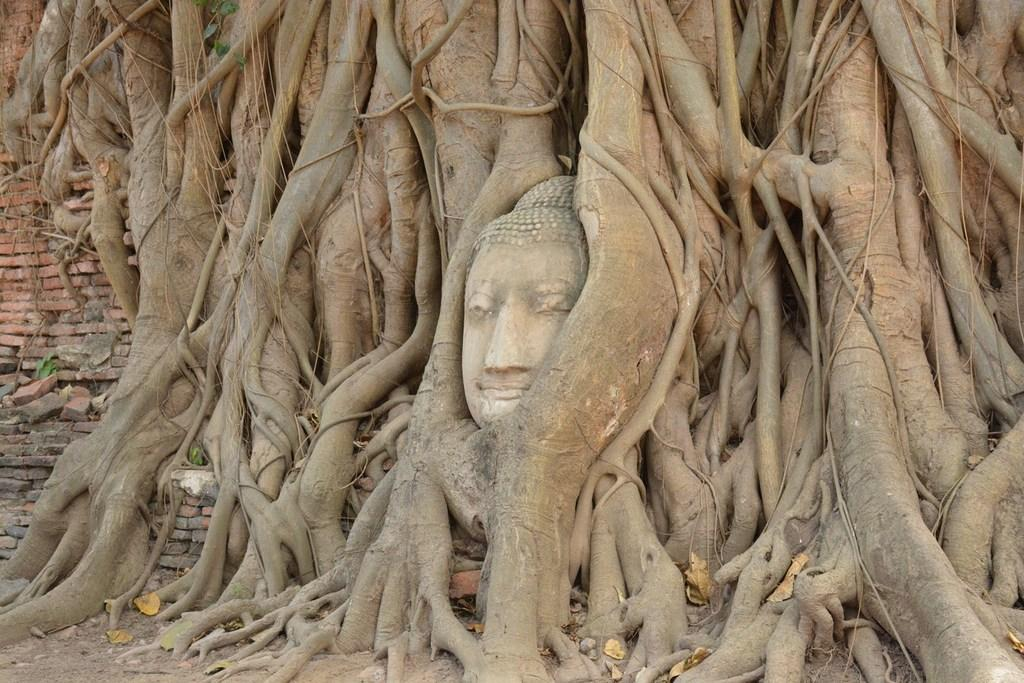What is the main subject of the image? There is a sculpture in the image. What type of material is used for the wooden barks in the image? The wooden barks in the image are made of wood. What other material can be seen in the image besides wood? There are bricks in the image. What color is the underwear worn by the geese in the image? There are no geese or underwear present in the image. What type of shock can be seen in the image? There is no shock present in the image. 